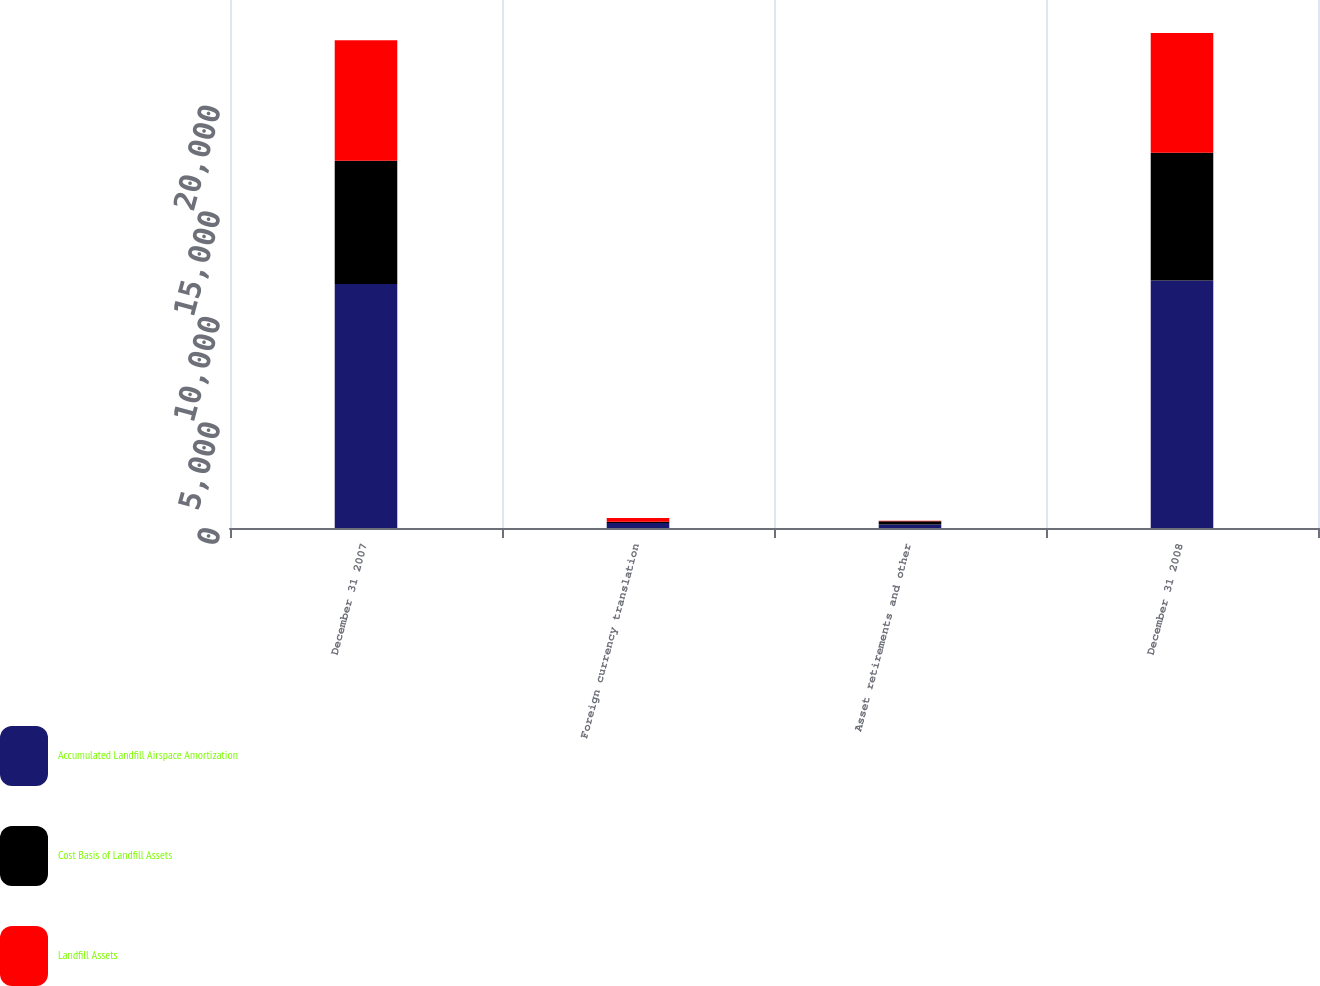<chart> <loc_0><loc_0><loc_500><loc_500><stacked_bar_chart><ecel><fcel>December 31 2007<fcel>Foreign currency translation<fcel>Asset retirements and other<fcel>December 31 2008<nl><fcel>Accumulated Landfill Airspace Amortization<fcel>11549<fcel>234<fcel>169<fcel>11716<nl><fcel>Cost Basis of Landfill Assets<fcel>5834<fcel>61<fcel>149<fcel>6053<nl><fcel>Landfill Assets<fcel>5715<fcel>173<fcel>20<fcel>5663<nl></chart> 